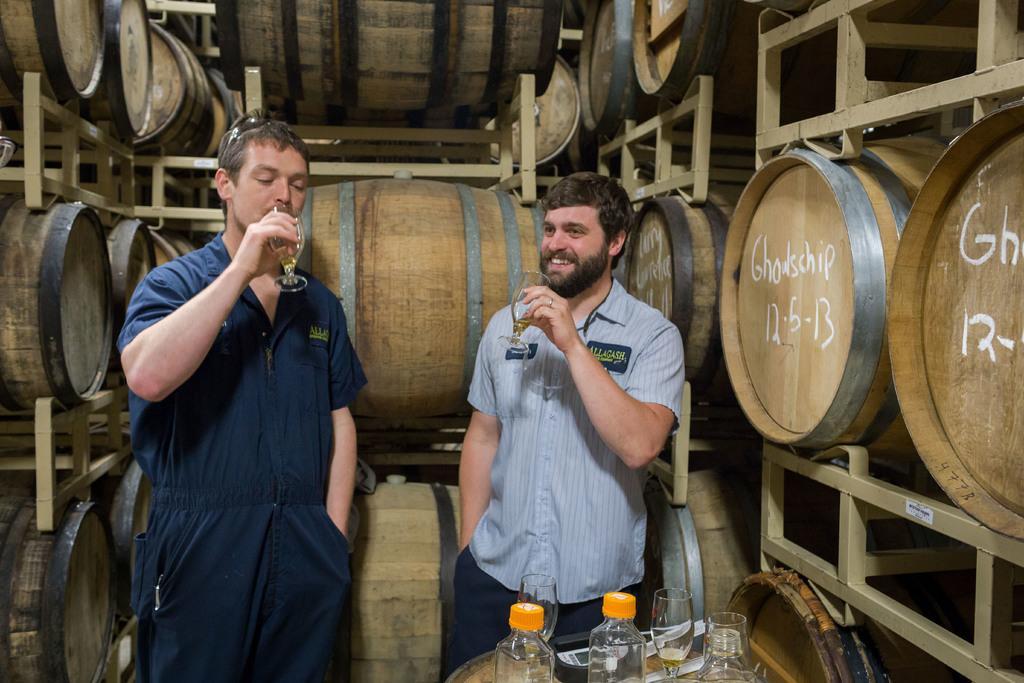Can you describe this image briefly? In this picture I can observe two men holding glasses in their hands. One of them is smiling. In the bottom of the picture I can observe a table on which bottles and glasses are placed. In the background I can observe barrels. 